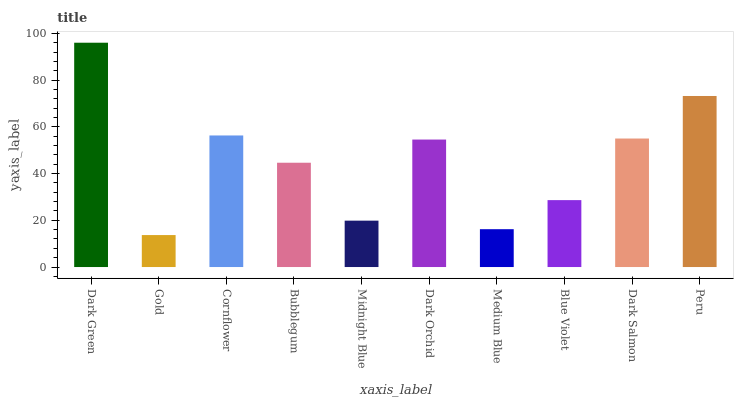Is Gold the minimum?
Answer yes or no. Yes. Is Dark Green the maximum?
Answer yes or no. Yes. Is Cornflower the minimum?
Answer yes or no. No. Is Cornflower the maximum?
Answer yes or no. No. Is Cornflower greater than Gold?
Answer yes or no. Yes. Is Gold less than Cornflower?
Answer yes or no. Yes. Is Gold greater than Cornflower?
Answer yes or no. No. Is Cornflower less than Gold?
Answer yes or no. No. Is Dark Orchid the high median?
Answer yes or no. Yes. Is Bubblegum the low median?
Answer yes or no. Yes. Is Dark Salmon the high median?
Answer yes or no. No. Is Medium Blue the low median?
Answer yes or no. No. 